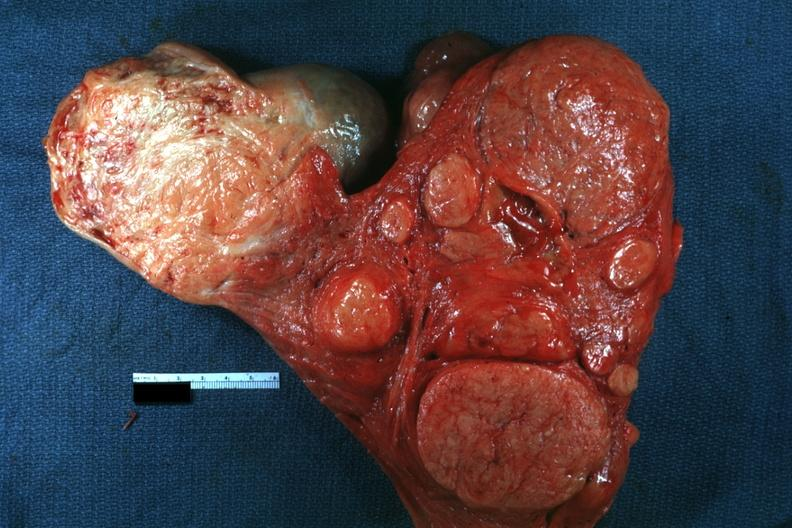what is present?
Answer the question using a single word or phrase. Female reproductive 